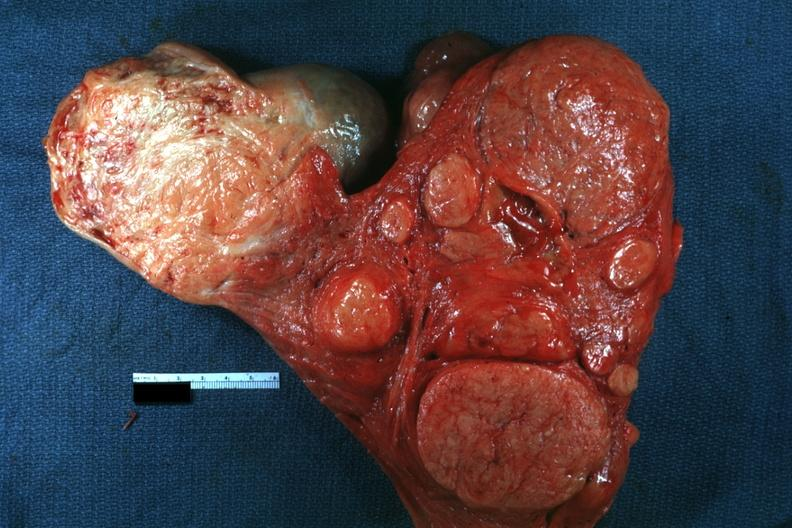what is present?
Answer the question using a single word or phrase. Female reproductive 